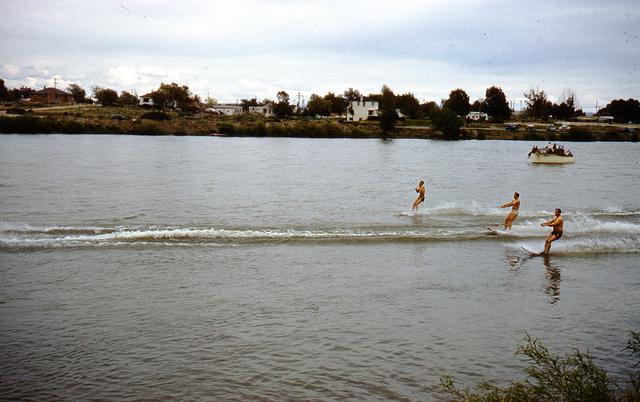Why are the men reaching forward while on skis?

Choices:
A) to swim
B) to wave
C) waterskiing
D) to dance waterskiing 